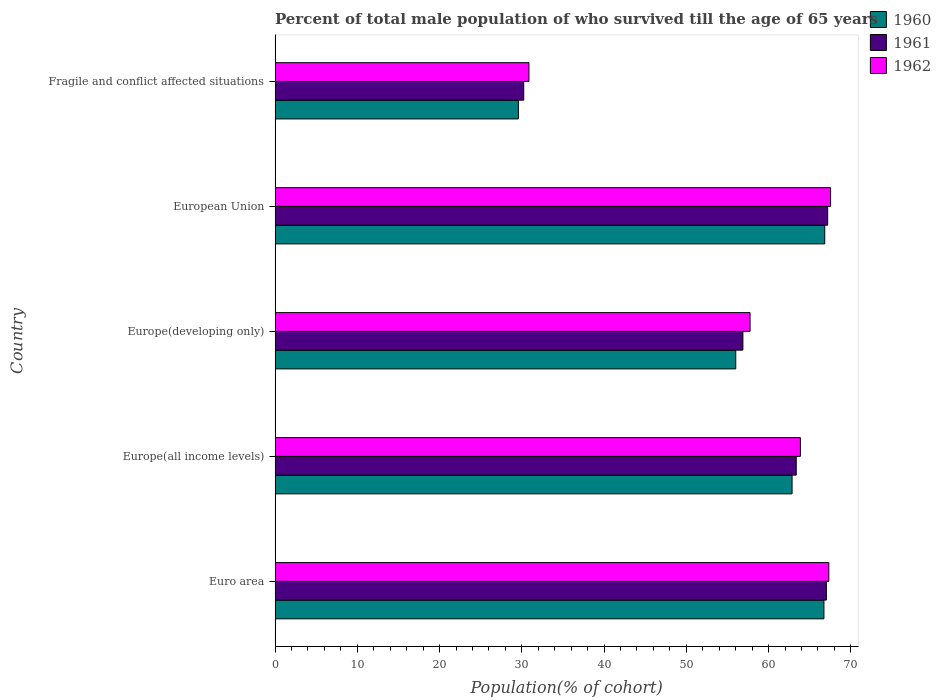How many groups of bars are there?
Your answer should be compact. 5. Are the number of bars per tick equal to the number of legend labels?
Provide a short and direct response. Yes. What is the label of the 3rd group of bars from the top?
Your answer should be very brief. Europe(developing only). What is the percentage of total male population who survived till the age of 65 years in 1961 in European Union?
Keep it short and to the point. 67.18. Across all countries, what is the maximum percentage of total male population who survived till the age of 65 years in 1962?
Offer a terse response. 67.54. Across all countries, what is the minimum percentage of total male population who survived till the age of 65 years in 1961?
Give a very brief answer. 30.23. In which country was the percentage of total male population who survived till the age of 65 years in 1960 maximum?
Your answer should be very brief. European Union. In which country was the percentage of total male population who survived till the age of 65 years in 1961 minimum?
Your answer should be very brief. Fragile and conflict affected situations. What is the total percentage of total male population who survived till the age of 65 years in 1962 in the graph?
Your answer should be very brief. 287.34. What is the difference between the percentage of total male population who survived till the age of 65 years in 1961 in Europe(all income levels) and that in European Union?
Offer a very short reply. -3.82. What is the difference between the percentage of total male population who survived till the age of 65 years in 1961 in Europe(developing only) and the percentage of total male population who survived till the age of 65 years in 1960 in Fragile and conflict affected situations?
Make the answer very short. 27.29. What is the average percentage of total male population who survived till the age of 65 years in 1960 per country?
Offer a terse response. 56.4. What is the difference between the percentage of total male population who survived till the age of 65 years in 1962 and percentage of total male population who survived till the age of 65 years in 1960 in Fragile and conflict affected situations?
Provide a short and direct response. 1.28. What is the ratio of the percentage of total male population who survived till the age of 65 years in 1960 in Europe(all income levels) to that in Europe(developing only)?
Offer a terse response. 1.12. Is the percentage of total male population who survived till the age of 65 years in 1960 in Euro area less than that in European Union?
Provide a succinct answer. Yes. What is the difference between the highest and the second highest percentage of total male population who survived till the age of 65 years in 1961?
Provide a short and direct response. 0.16. What is the difference between the highest and the lowest percentage of total male population who survived till the age of 65 years in 1960?
Ensure brevity in your answer.  37.24. In how many countries, is the percentage of total male population who survived till the age of 65 years in 1961 greater than the average percentage of total male population who survived till the age of 65 years in 1961 taken over all countries?
Keep it short and to the point. 3. What does the 1st bar from the top in European Union represents?
Ensure brevity in your answer.  1962. What does the 3rd bar from the bottom in Europe(all income levels) represents?
Offer a terse response. 1962. How many bars are there?
Make the answer very short. 15. What is the difference between two consecutive major ticks on the X-axis?
Provide a succinct answer. 10. Does the graph contain any zero values?
Ensure brevity in your answer.  No. Where does the legend appear in the graph?
Provide a succinct answer. Top right. How many legend labels are there?
Ensure brevity in your answer.  3. How are the legend labels stacked?
Your answer should be very brief. Vertical. What is the title of the graph?
Keep it short and to the point. Percent of total male population of who survived till the age of 65 years. What is the label or title of the X-axis?
Ensure brevity in your answer.  Population(% of cohort). What is the label or title of the Y-axis?
Your response must be concise. Country. What is the Population(% of cohort) of 1960 in Euro area?
Ensure brevity in your answer.  66.73. What is the Population(% of cohort) in 1961 in Euro area?
Offer a very short reply. 67.03. What is the Population(% of cohort) in 1962 in Euro area?
Offer a terse response. 67.32. What is the Population(% of cohort) of 1960 in Europe(all income levels)?
Give a very brief answer. 62.85. What is the Population(% of cohort) in 1961 in Europe(all income levels)?
Provide a short and direct response. 63.36. What is the Population(% of cohort) of 1962 in Europe(all income levels)?
Your answer should be compact. 63.87. What is the Population(% of cohort) of 1960 in Europe(developing only)?
Your answer should be compact. 56.01. What is the Population(% of cohort) of 1961 in Europe(developing only)?
Give a very brief answer. 56.88. What is the Population(% of cohort) of 1962 in Europe(developing only)?
Provide a succinct answer. 57.75. What is the Population(% of cohort) in 1960 in European Union?
Offer a terse response. 66.83. What is the Population(% of cohort) of 1961 in European Union?
Your response must be concise. 67.18. What is the Population(% of cohort) of 1962 in European Union?
Keep it short and to the point. 67.54. What is the Population(% of cohort) in 1960 in Fragile and conflict affected situations?
Your response must be concise. 29.58. What is the Population(% of cohort) of 1961 in Fragile and conflict affected situations?
Give a very brief answer. 30.23. What is the Population(% of cohort) of 1962 in Fragile and conflict affected situations?
Ensure brevity in your answer.  30.86. Across all countries, what is the maximum Population(% of cohort) in 1960?
Your answer should be very brief. 66.83. Across all countries, what is the maximum Population(% of cohort) in 1961?
Make the answer very short. 67.18. Across all countries, what is the maximum Population(% of cohort) of 1962?
Your answer should be very brief. 67.54. Across all countries, what is the minimum Population(% of cohort) of 1960?
Give a very brief answer. 29.58. Across all countries, what is the minimum Population(% of cohort) in 1961?
Your response must be concise. 30.23. Across all countries, what is the minimum Population(% of cohort) in 1962?
Offer a very short reply. 30.86. What is the total Population(% of cohort) of 1960 in the graph?
Your answer should be very brief. 282. What is the total Population(% of cohort) in 1961 in the graph?
Offer a very short reply. 284.67. What is the total Population(% of cohort) in 1962 in the graph?
Offer a very short reply. 287.34. What is the difference between the Population(% of cohort) in 1960 in Euro area and that in Europe(all income levels)?
Keep it short and to the point. 3.87. What is the difference between the Population(% of cohort) of 1961 in Euro area and that in Europe(all income levels)?
Ensure brevity in your answer.  3.67. What is the difference between the Population(% of cohort) in 1962 in Euro area and that in Europe(all income levels)?
Make the answer very short. 3.45. What is the difference between the Population(% of cohort) in 1960 in Euro area and that in Europe(developing only)?
Your answer should be very brief. 10.72. What is the difference between the Population(% of cohort) of 1961 in Euro area and that in Europe(developing only)?
Your answer should be very brief. 10.15. What is the difference between the Population(% of cohort) of 1962 in Euro area and that in Europe(developing only)?
Your answer should be compact. 9.57. What is the difference between the Population(% of cohort) in 1960 in Euro area and that in European Union?
Offer a very short reply. -0.1. What is the difference between the Population(% of cohort) in 1961 in Euro area and that in European Union?
Give a very brief answer. -0.16. What is the difference between the Population(% of cohort) of 1962 in Euro area and that in European Union?
Ensure brevity in your answer.  -0.22. What is the difference between the Population(% of cohort) of 1960 in Euro area and that in Fragile and conflict affected situations?
Provide a succinct answer. 37.15. What is the difference between the Population(% of cohort) of 1961 in Euro area and that in Fragile and conflict affected situations?
Offer a terse response. 36.8. What is the difference between the Population(% of cohort) in 1962 in Euro area and that in Fragile and conflict affected situations?
Your response must be concise. 36.46. What is the difference between the Population(% of cohort) in 1960 in Europe(all income levels) and that in Europe(developing only)?
Offer a very short reply. 6.85. What is the difference between the Population(% of cohort) of 1961 in Europe(all income levels) and that in Europe(developing only)?
Your response must be concise. 6.49. What is the difference between the Population(% of cohort) of 1962 in Europe(all income levels) and that in Europe(developing only)?
Your answer should be compact. 6.12. What is the difference between the Population(% of cohort) of 1960 in Europe(all income levels) and that in European Union?
Provide a short and direct response. -3.97. What is the difference between the Population(% of cohort) of 1961 in Europe(all income levels) and that in European Union?
Provide a succinct answer. -3.82. What is the difference between the Population(% of cohort) in 1962 in Europe(all income levels) and that in European Union?
Provide a short and direct response. -3.67. What is the difference between the Population(% of cohort) of 1960 in Europe(all income levels) and that in Fragile and conflict affected situations?
Offer a very short reply. 33.27. What is the difference between the Population(% of cohort) in 1961 in Europe(all income levels) and that in Fragile and conflict affected situations?
Give a very brief answer. 33.13. What is the difference between the Population(% of cohort) of 1962 in Europe(all income levels) and that in Fragile and conflict affected situations?
Offer a very short reply. 33. What is the difference between the Population(% of cohort) in 1960 in Europe(developing only) and that in European Union?
Your response must be concise. -10.82. What is the difference between the Population(% of cohort) of 1961 in Europe(developing only) and that in European Union?
Offer a very short reply. -10.31. What is the difference between the Population(% of cohort) of 1962 in Europe(developing only) and that in European Union?
Your answer should be very brief. -9.79. What is the difference between the Population(% of cohort) in 1960 in Europe(developing only) and that in Fragile and conflict affected situations?
Offer a terse response. 26.43. What is the difference between the Population(% of cohort) in 1961 in Europe(developing only) and that in Fragile and conflict affected situations?
Keep it short and to the point. 26.65. What is the difference between the Population(% of cohort) of 1962 in Europe(developing only) and that in Fragile and conflict affected situations?
Ensure brevity in your answer.  26.88. What is the difference between the Population(% of cohort) of 1960 in European Union and that in Fragile and conflict affected situations?
Offer a very short reply. 37.24. What is the difference between the Population(% of cohort) of 1961 in European Union and that in Fragile and conflict affected situations?
Make the answer very short. 36.95. What is the difference between the Population(% of cohort) of 1962 in European Union and that in Fragile and conflict affected situations?
Give a very brief answer. 36.67. What is the difference between the Population(% of cohort) of 1960 in Euro area and the Population(% of cohort) of 1961 in Europe(all income levels)?
Keep it short and to the point. 3.37. What is the difference between the Population(% of cohort) in 1960 in Euro area and the Population(% of cohort) in 1962 in Europe(all income levels)?
Provide a short and direct response. 2.86. What is the difference between the Population(% of cohort) in 1961 in Euro area and the Population(% of cohort) in 1962 in Europe(all income levels)?
Ensure brevity in your answer.  3.16. What is the difference between the Population(% of cohort) in 1960 in Euro area and the Population(% of cohort) in 1961 in Europe(developing only)?
Ensure brevity in your answer.  9.85. What is the difference between the Population(% of cohort) in 1960 in Euro area and the Population(% of cohort) in 1962 in Europe(developing only)?
Give a very brief answer. 8.98. What is the difference between the Population(% of cohort) in 1961 in Euro area and the Population(% of cohort) in 1962 in Europe(developing only)?
Ensure brevity in your answer.  9.28. What is the difference between the Population(% of cohort) in 1960 in Euro area and the Population(% of cohort) in 1961 in European Union?
Offer a terse response. -0.45. What is the difference between the Population(% of cohort) in 1960 in Euro area and the Population(% of cohort) in 1962 in European Union?
Keep it short and to the point. -0.81. What is the difference between the Population(% of cohort) of 1961 in Euro area and the Population(% of cohort) of 1962 in European Union?
Provide a succinct answer. -0.51. What is the difference between the Population(% of cohort) in 1960 in Euro area and the Population(% of cohort) in 1961 in Fragile and conflict affected situations?
Keep it short and to the point. 36.5. What is the difference between the Population(% of cohort) of 1960 in Euro area and the Population(% of cohort) of 1962 in Fragile and conflict affected situations?
Ensure brevity in your answer.  35.86. What is the difference between the Population(% of cohort) of 1961 in Euro area and the Population(% of cohort) of 1962 in Fragile and conflict affected situations?
Your response must be concise. 36.16. What is the difference between the Population(% of cohort) in 1960 in Europe(all income levels) and the Population(% of cohort) in 1961 in Europe(developing only)?
Your answer should be very brief. 5.98. What is the difference between the Population(% of cohort) of 1960 in Europe(all income levels) and the Population(% of cohort) of 1962 in Europe(developing only)?
Your response must be concise. 5.11. What is the difference between the Population(% of cohort) in 1961 in Europe(all income levels) and the Population(% of cohort) in 1962 in Europe(developing only)?
Your answer should be compact. 5.61. What is the difference between the Population(% of cohort) of 1960 in Europe(all income levels) and the Population(% of cohort) of 1961 in European Union?
Keep it short and to the point. -4.33. What is the difference between the Population(% of cohort) in 1960 in Europe(all income levels) and the Population(% of cohort) in 1962 in European Union?
Ensure brevity in your answer.  -4.68. What is the difference between the Population(% of cohort) of 1961 in Europe(all income levels) and the Population(% of cohort) of 1962 in European Union?
Provide a short and direct response. -4.18. What is the difference between the Population(% of cohort) of 1960 in Europe(all income levels) and the Population(% of cohort) of 1961 in Fragile and conflict affected situations?
Provide a short and direct response. 32.62. What is the difference between the Population(% of cohort) of 1960 in Europe(all income levels) and the Population(% of cohort) of 1962 in Fragile and conflict affected situations?
Your response must be concise. 31.99. What is the difference between the Population(% of cohort) of 1961 in Europe(all income levels) and the Population(% of cohort) of 1962 in Fragile and conflict affected situations?
Keep it short and to the point. 32.5. What is the difference between the Population(% of cohort) of 1960 in Europe(developing only) and the Population(% of cohort) of 1961 in European Union?
Your response must be concise. -11.17. What is the difference between the Population(% of cohort) of 1960 in Europe(developing only) and the Population(% of cohort) of 1962 in European Union?
Make the answer very short. -11.53. What is the difference between the Population(% of cohort) of 1961 in Europe(developing only) and the Population(% of cohort) of 1962 in European Union?
Provide a succinct answer. -10.66. What is the difference between the Population(% of cohort) of 1960 in Europe(developing only) and the Population(% of cohort) of 1961 in Fragile and conflict affected situations?
Provide a succinct answer. 25.78. What is the difference between the Population(% of cohort) in 1960 in Europe(developing only) and the Population(% of cohort) in 1962 in Fragile and conflict affected situations?
Ensure brevity in your answer.  25.14. What is the difference between the Population(% of cohort) in 1961 in Europe(developing only) and the Population(% of cohort) in 1962 in Fragile and conflict affected situations?
Keep it short and to the point. 26.01. What is the difference between the Population(% of cohort) in 1960 in European Union and the Population(% of cohort) in 1961 in Fragile and conflict affected situations?
Ensure brevity in your answer.  36.6. What is the difference between the Population(% of cohort) of 1960 in European Union and the Population(% of cohort) of 1962 in Fragile and conflict affected situations?
Your answer should be very brief. 35.96. What is the difference between the Population(% of cohort) of 1961 in European Union and the Population(% of cohort) of 1962 in Fragile and conflict affected situations?
Make the answer very short. 36.32. What is the average Population(% of cohort) in 1960 per country?
Your answer should be very brief. 56.4. What is the average Population(% of cohort) of 1961 per country?
Provide a succinct answer. 56.93. What is the average Population(% of cohort) of 1962 per country?
Ensure brevity in your answer.  57.47. What is the difference between the Population(% of cohort) of 1960 and Population(% of cohort) of 1961 in Euro area?
Provide a short and direct response. -0.3. What is the difference between the Population(% of cohort) in 1960 and Population(% of cohort) in 1962 in Euro area?
Give a very brief answer. -0.59. What is the difference between the Population(% of cohort) of 1961 and Population(% of cohort) of 1962 in Euro area?
Ensure brevity in your answer.  -0.3. What is the difference between the Population(% of cohort) in 1960 and Population(% of cohort) in 1961 in Europe(all income levels)?
Provide a succinct answer. -0.51. What is the difference between the Population(% of cohort) in 1960 and Population(% of cohort) in 1962 in Europe(all income levels)?
Your answer should be compact. -1.01. What is the difference between the Population(% of cohort) of 1961 and Population(% of cohort) of 1962 in Europe(all income levels)?
Your answer should be very brief. -0.51. What is the difference between the Population(% of cohort) in 1960 and Population(% of cohort) in 1961 in Europe(developing only)?
Keep it short and to the point. -0.87. What is the difference between the Population(% of cohort) of 1960 and Population(% of cohort) of 1962 in Europe(developing only)?
Offer a very short reply. -1.74. What is the difference between the Population(% of cohort) in 1961 and Population(% of cohort) in 1962 in Europe(developing only)?
Give a very brief answer. -0.87. What is the difference between the Population(% of cohort) of 1960 and Population(% of cohort) of 1961 in European Union?
Offer a terse response. -0.36. What is the difference between the Population(% of cohort) of 1960 and Population(% of cohort) of 1962 in European Union?
Your answer should be compact. -0.71. What is the difference between the Population(% of cohort) in 1961 and Population(% of cohort) in 1962 in European Union?
Offer a very short reply. -0.36. What is the difference between the Population(% of cohort) of 1960 and Population(% of cohort) of 1961 in Fragile and conflict affected situations?
Make the answer very short. -0.65. What is the difference between the Population(% of cohort) in 1960 and Population(% of cohort) in 1962 in Fragile and conflict affected situations?
Your answer should be compact. -1.28. What is the difference between the Population(% of cohort) in 1961 and Population(% of cohort) in 1962 in Fragile and conflict affected situations?
Your answer should be very brief. -0.63. What is the ratio of the Population(% of cohort) of 1960 in Euro area to that in Europe(all income levels)?
Keep it short and to the point. 1.06. What is the ratio of the Population(% of cohort) of 1961 in Euro area to that in Europe(all income levels)?
Ensure brevity in your answer.  1.06. What is the ratio of the Population(% of cohort) of 1962 in Euro area to that in Europe(all income levels)?
Provide a succinct answer. 1.05. What is the ratio of the Population(% of cohort) in 1960 in Euro area to that in Europe(developing only)?
Offer a terse response. 1.19. What is the ratio of the Population(% of cohort) of 1961 in Euro area to that in Europe(developing only)?
Offer a terse response. 1.18. What is the ratio of the Population(% of cohort) in 1962 in Euro area to that in Europe(developing only)?
Offer a very short reply. 1.17. What is the ratio of the Population(% of cohort) in 1960 in Euro area to that in European Union?
Give a very brief answer. 1. What is the ratio of the Population(% of cohort) of 1961 in Euro area to that in European Union?
Your answer should be very brief. 1. What is the ratio of the Population(% of cohort) of 1960 in Euro area to that in Fragile and conflict affected situations?
Offer a very short reply. 2.26. What is the ratio of the Population(% of cohort) of 1961 in Euro area to that in Fragile and conflict affected situations?
Offer a terse response. 2.22. What is the ratio of the Population(% of cohort) of 1962 in Euro area to that in Fragile and conflict affected situations?
Keep it short and to the point. 2.18. What is the ratio of the Population(% of cohort) in 1960 in Europe(all income levels) to that in Europe(developing only)?
Make the answer very short. 1.12. What is the ratio of the Population(% of cohort) in 1961 in Europe(all income levels) to that in Europe(developing only)?
Make the answer very short. 1.11. What is the ratio of the Population(% of cohort) in 1962 in Europe(all income levels) to that in Europe(developing only)?
Keep it short and to the point. 1.11. What is the ratio of the Population(% of cohort) in 1960 in Europe(all income levels) to that in European Union?
Keep it short and to the point. 0.94. What is the ratio of the Population(% of cohort) in 1961 in Europe(all income levels) to that in European Union?
Provide a short and direct response. 0.94. What is the ratio of the Population(% of cohort) in 1962 in Europe(all income levels) to that in European Union?
Ensure brevity in your answer.  0.95. What is the ratio of the Population(% of cohort) in 1960 in Europe(all income levels) to that in Fragile and conflict affected situations?
Offer a terse response. 2.12. What is the ratio of the Population(% of cohort) of 1961 in Europe(all income levels) to that in Fragile and conflict affected situations?
Your answer should be very brief. 2.1. What is the ratio of the Population(% of cohort) of 1962 in Europe(all income levels) to that in Fragile and conflict affected situations?
Keep it short and to the point. 2.07. What is the ratio of the Population(% of cohort) in 1960 in Europe(developing only) to that in European Union?
Your response must be concise. 0.84. What is the ratio of the Population(% of cohort) in 1961 in Europe(developing only) to that in European Union?
Ensure brevity in your answer.  0.85. What is the ratio of the Population(% of cohort) in 1962 in Europe(developing only) to that in European Union?
Keep it short and to the point. 0.85. What is the ratio of the Population(% of cohort) in 1960 in Europe(developing only) to that in Fragile and conflict affected situations?
Provide a short and direct response. 1.89. What is the ratio of the Population(% of cohort) of 1961 in Europe(developing only) to that in Fragile and conflict affected situations?
Offer a terse response. 1.88. What is the ratio of the Population(% of cohort) in 1962 in Europe(developing only) to that in Fragile and conflict affected situations?
Your response must be concise. 1.87. What is the ratio of the Population(% of cohort) of 1960 in European Union to that in Fragile and conflict affected situations?
Your answer should be compact. 2.26. What is the ratio of the Population(% of cohort) of 1961 in European Union to that in Fragile and conflict affected situations?
Provide a short and direct response. 2.22. What is the ratio of the Population(% of cohort) in 1962 in European Union to that in Fragile and conflict affected situations?
Provide a short and direct response. 2.19. What is the difference between the highest and the second highest Population(% of cohort) of 1960?
Offer a terse response. 0.1. What is the difference between the highest and the second highest Population(% of cohort) of 1961?
Your answer should be very brief. 0.16. What is the difference between the highest and the second highest Population(% of cohort) of 1962?
Your answer should be very brief. 0.22. What is the difference between the highest and the lowest Population(% of cohort) of 1960?
Your response must be concise. 37.24. What is the difference between the highest and the lowest Population(% of cohort) in 1961?
Give a very brief answer. 36.95. What is the difference between the highest and the lowest Population(% of cohort) of 1962?
Offer a very short reply. 36.67. 